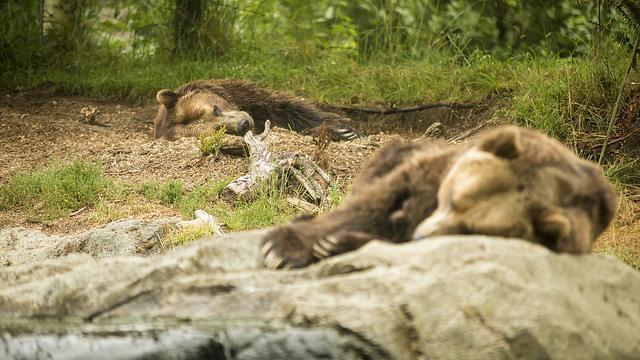How many animals are shown?
Give a very brief answer. 2. How many bears in the tree?
Give a very brief answer. 0. How many bears can be seen?
Give a very brief answer. 2. 